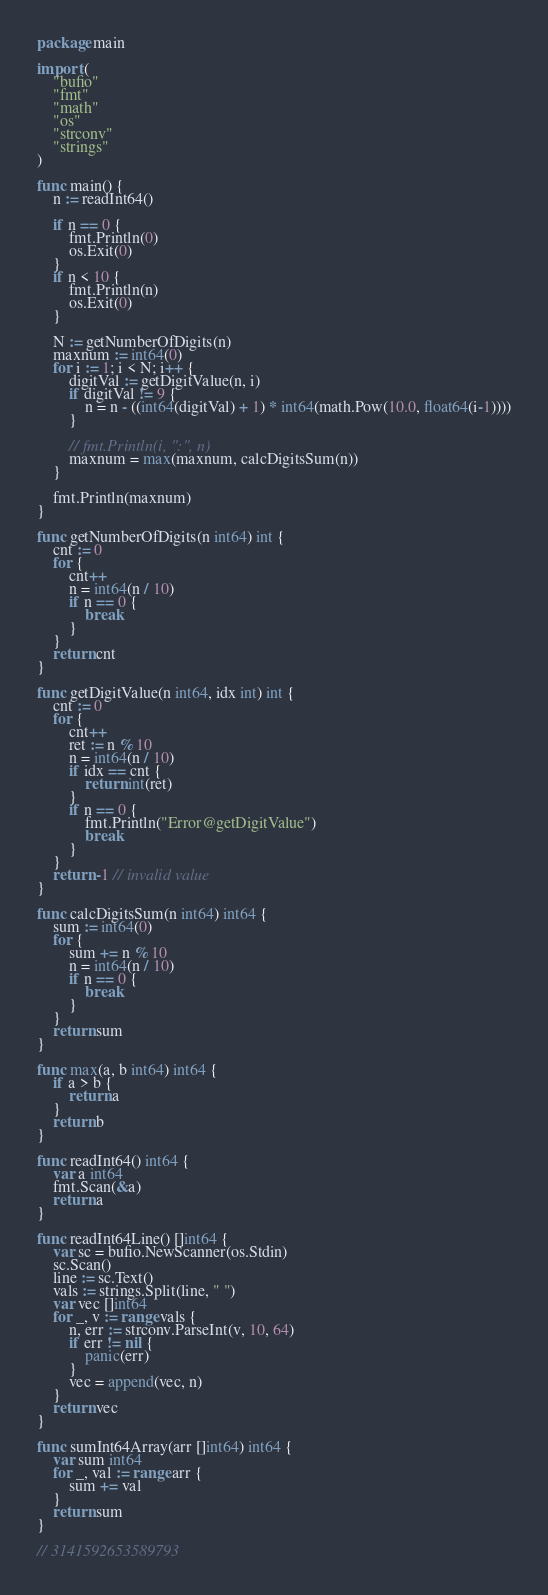Convert code to text. <code><loc_0><loc_0><loc_500><loc_500><_Go_>package main

import (
	"bufio"
	"fmt"
	"math"
	"os"
	"strconv"
	"strings"
)

func main() {
	n := readInt64()

	if n == 0 {
		fmt.Println(0)
		os.Exit(0)
	}
	if n < 10 {
		fmt.Println(n)
		os.Exit(0)
	}

	N := getNumberOfDigits(n)
	maxnum := int64(0)
	for i := 1; i < N; i++ {
		digitVal := getDigitValue(n, i)
		if digitVal != 9 {
			n = n - ((int64(digitVal) + 1) * int64(math.Pow(10.0, float64(i-1))))
		}

		// fmt.Println(i, ":", n)
		maxnum = max(maxnum, calcDigitsSum(n))
	}

	fmt.Println(maxnum)
}

func getNumberOfDigits(n int64) int {
	cnt := 0
	for {
		cnt++
		n = int64(n / 10)
		if n == 0 {
			break
		}
	}
	return cnt
}

func getDigitValue(n int64, idx int) int {
	cnt := 0
	for {
		cnt++
		ret := n % 10
		n = int64(n / 10)
		if idx == cnt {
			return int(ret)
		}
		if n == 0 {
			fmt.Println("Error@getDigitValue")
			break
		}
	}
	return -1 // invalid value
}

func calcDigitsSum(n int64) int64 {
	sum := int64(0)
	for {
		sum += n % 10
		n = int64(n / 10)
		if n == 0 {
			break
		}
	}
	return sum
}

func max(a, b int64) int64 {
	if a > b {
		return a
	}
	return b
}

func readInt64() int64 {
	var a int64
	fmt.Scan(&a)
	return a
}

func readInt64Line() []int64 {
	var sc = bufio.NewScanner(os.Stdin)
	sc.Scan()
	line := sc.Text()
	vals := strings.Split(line, " ")
	var vec []int64
	for _, v := range vals {
		n, err := strconv.ParseInt(v, 10, 64)
		if err != nil {
			panic(err)
		}
		vec = append(vec, n)
	}
	return vec
}

func sumInt64Array(arr []int64) int64 {
	var sum int64
	for _, val := range arr {
		sum += val
	}
	return sum
}

// 3141592653589793
</code> 